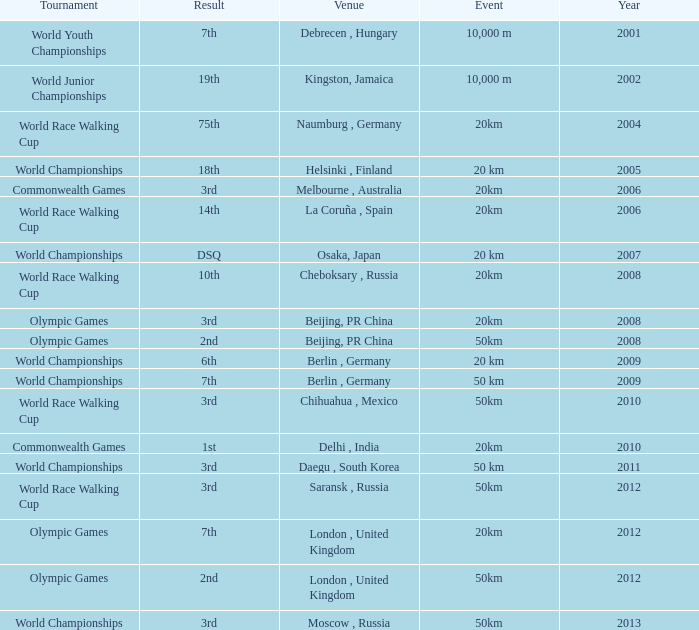What is the result of the World Race Walking Cup tournament played before the year 2010? 3rd. 